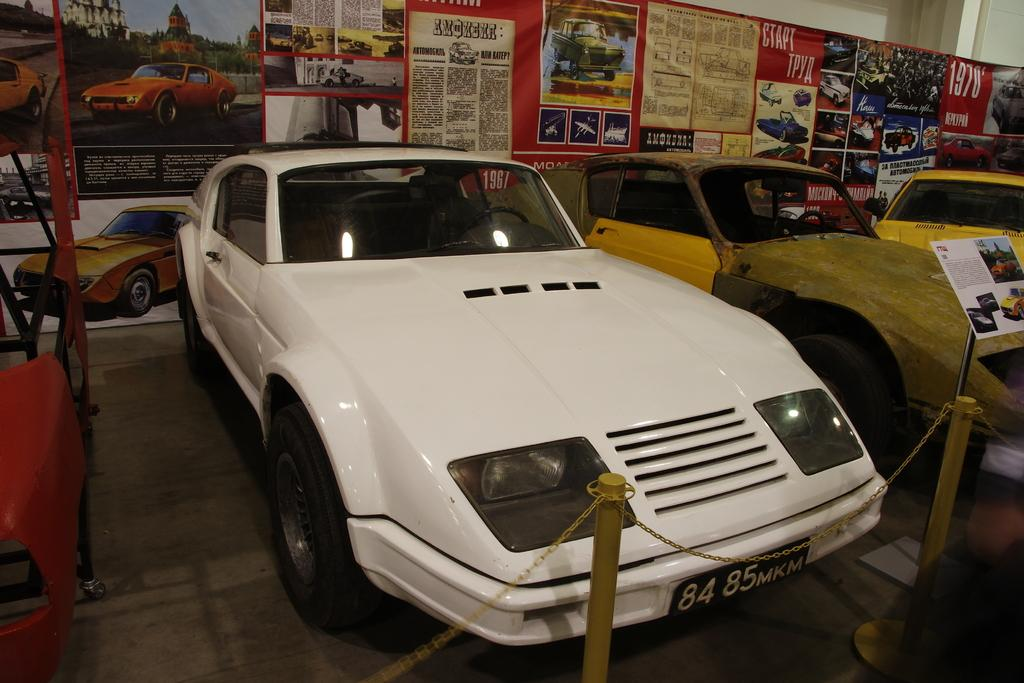What objects are on the floor in the image? There are motor vehicles on the floor in the image. What type of structures can be seen in the image? Iron poles are present in the image. What connects the iron poles in the image? A chain is visible in the image. What can be seen in the background of the image? There are advertisements in the background of the image. What type of cakes are being advertised in the image? There are no cakes present in the image, nor are there any advertisements for cakes. 